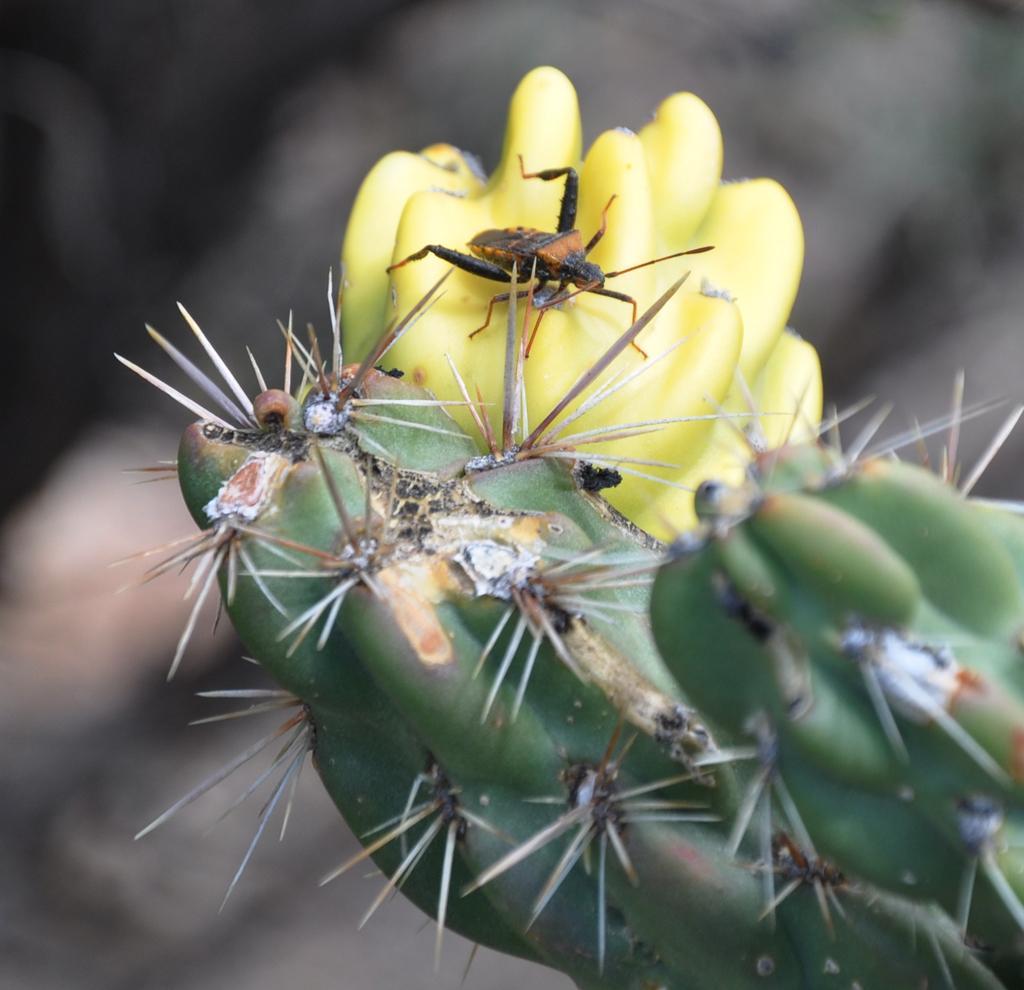Can you describe this image briefly? In this image there is a plant and a flower, on the flower there is an insect and there is a blurry background. 